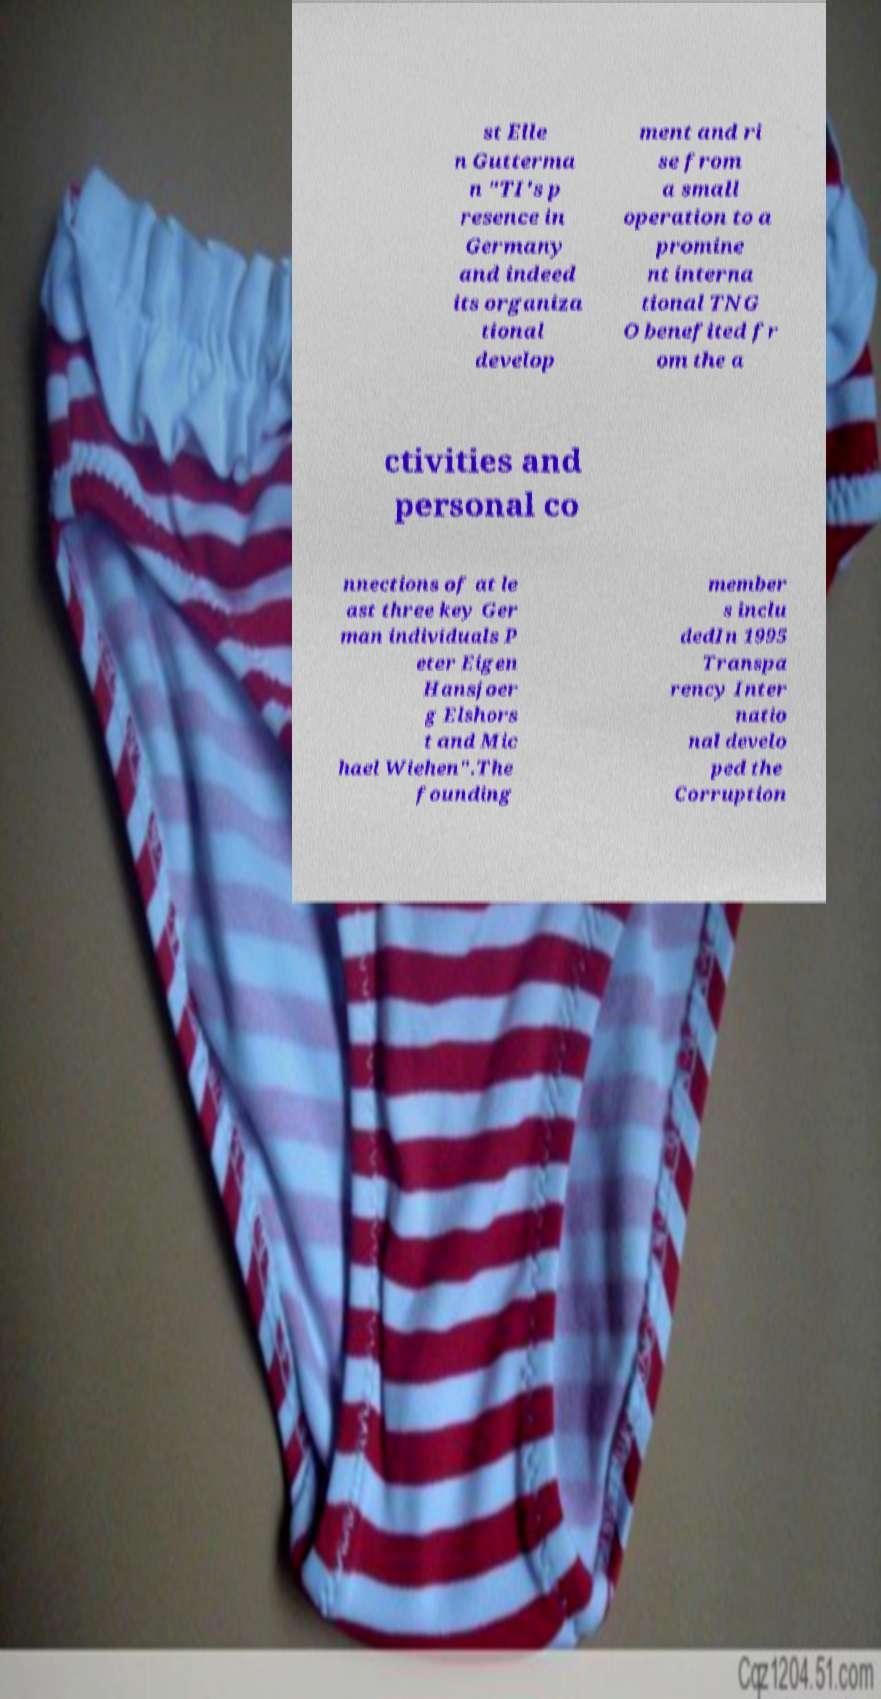There's text embedded in this image that I need extracted. Can you transcribe it verbatim? st Elle n Gutterma n "TI's p resence in Germany and indeed its organiza tional develop ment and ri se from a small operation to a promine nt interna tional TNG O benefited fr om the a ctivities and personal co nnections of at le ast three key Ger man individuals P eter Eigen Hansjoer g Elshors t and Mic hael Wiehen".The founding member s inclu dedIn 1995 Transpa rency Inter natio nal develo ped the Corruption 